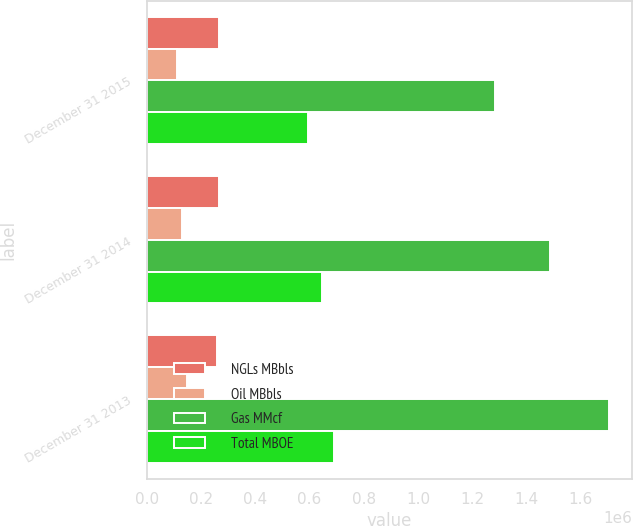<chart> <loc_0><loc_0><loc_500><loc_500><stacked_bar_chart><ecel><fcel>December 31 2015<fcel>December 31 2014<fcel>December 31 2013<nl><fcel>NGLs MBbls<fcel>266657<fcel>267193<fcel>256638<nl><fcel>Oil MBbls<fcel>112376<fcel>130206<fcel>148161<nl><fcel>Gas MMcf<fcel>1.28468e+06<fcel>1.48629e+06<fcel>1.70367e+06<nl><fcel>Total MBOE<fcel>593146<fcel>645113<fcel>688743<nl></chart> 